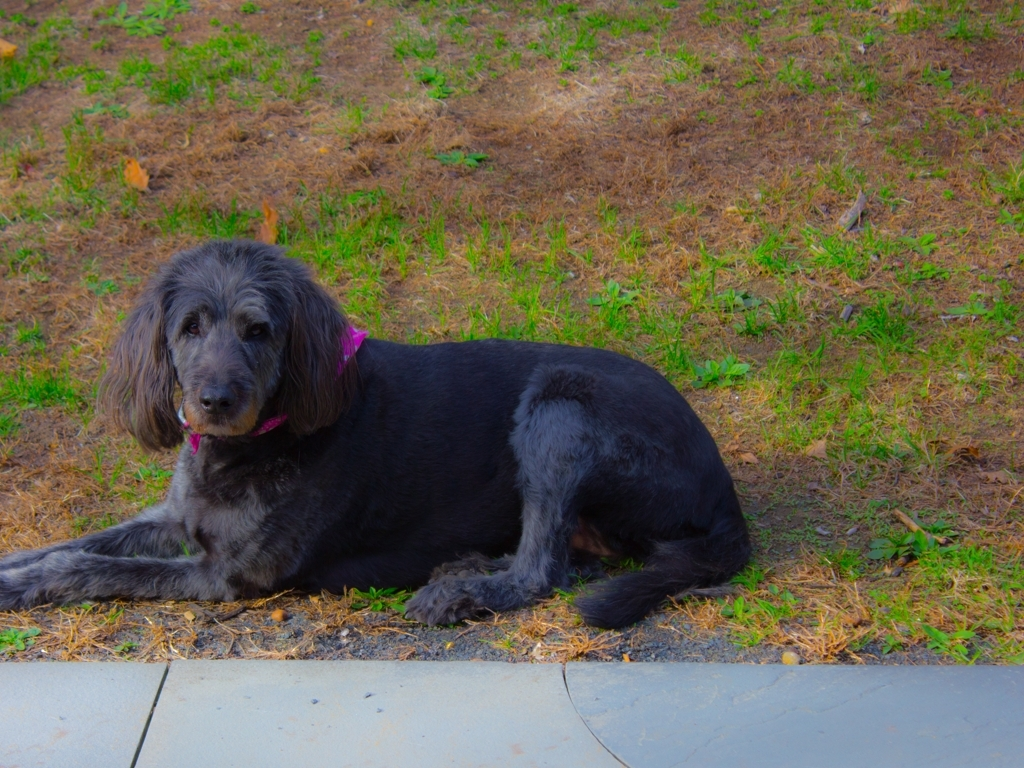Can you describe the setting the dog is in? The dog is lying down on a patchy grassy area with some dried leaves scattered around. The immediate foreground is a concrete edge, suggesting this may be a park or a backyard. It's a tranquil setting that appears to be well-suited for a relaxed dog. 